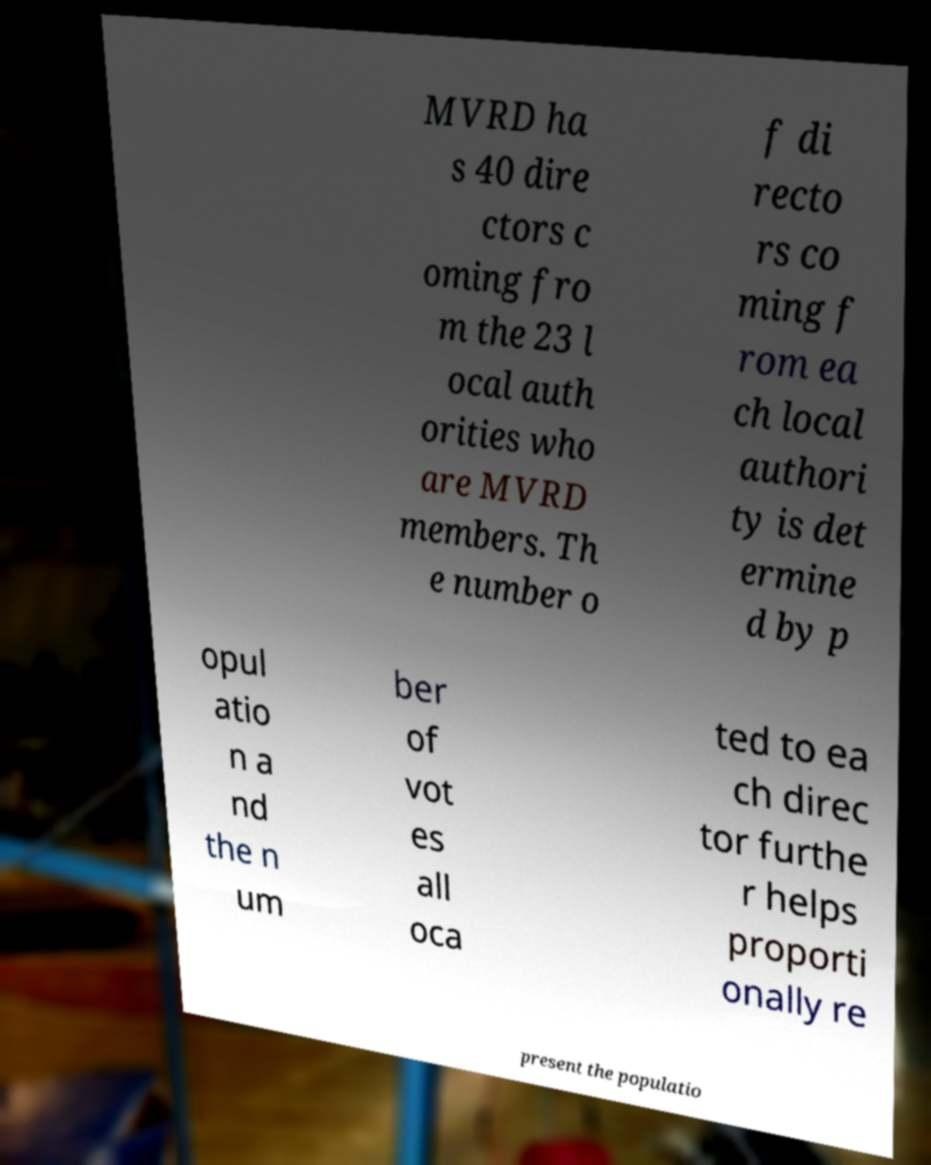Please read and relay the text visible in this image. What does it say? MVRD ha s 40 dire ctors c oming fro m the 23 l ocal auth orities who are MVRD members. Th e number o f di recto rs co ming f rom ea ch local authori ty is det ermine d by p opul atio n a nd the n um ber of vot es all oca ted to ea ch direc tor furthe r helps proporti onally re present the populatio 